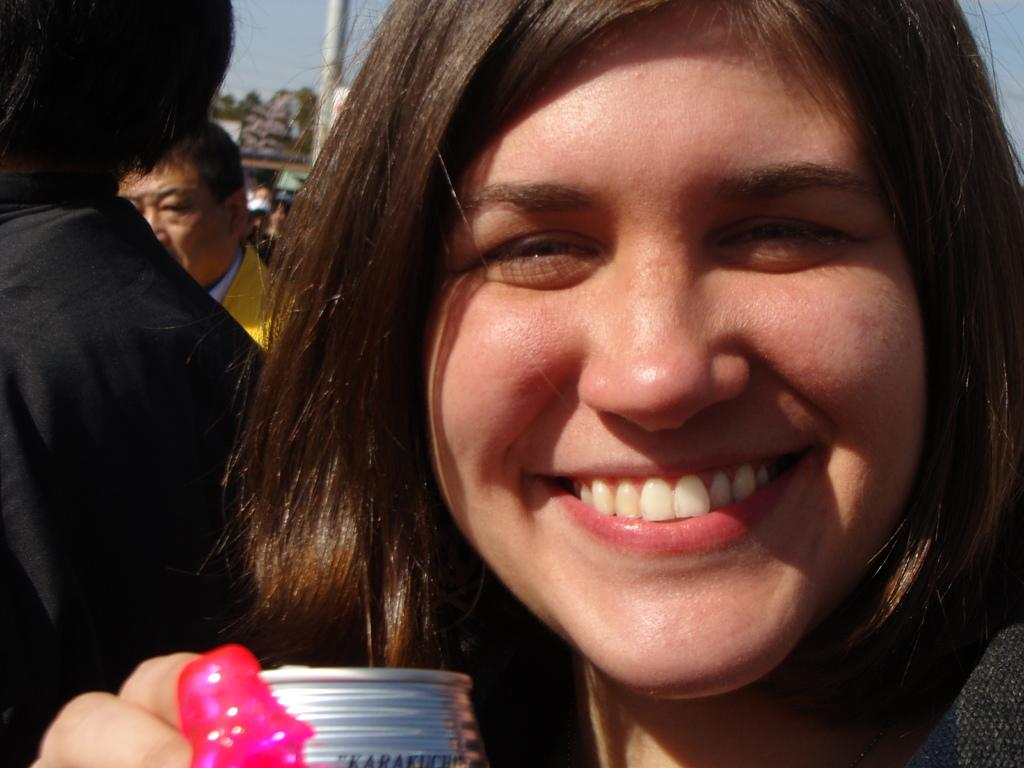Who is the main subject in the foreground of the image? There is a woman in the foreground of the image. What is the woman doing in the image? The woman is laughing. Are there any other people visible in the image? Yes, there are other people visible behind the woman. What type of seed can be seen growing in the woman's hair in the image? There is no seed visible in the woman's hair or anywhere else in the image. 